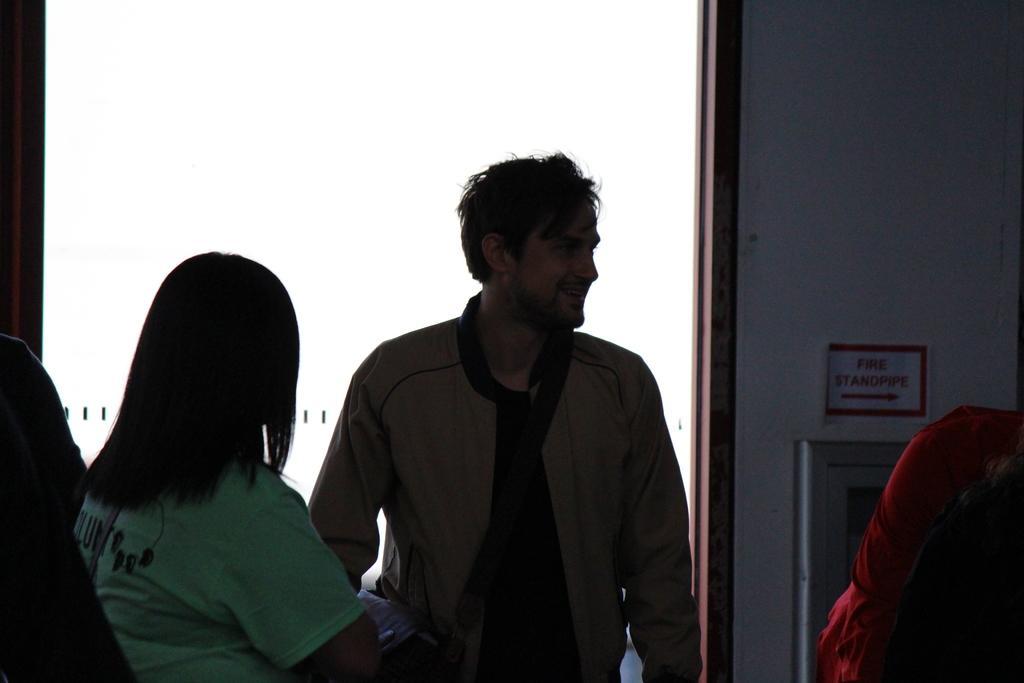Describe this image in one or two sentences. In this picture we can see two persons standing. Behind the two persons, there is a white background. On the right side of the image, there is a red colored object and there is a paper and an object attached to a wall. 